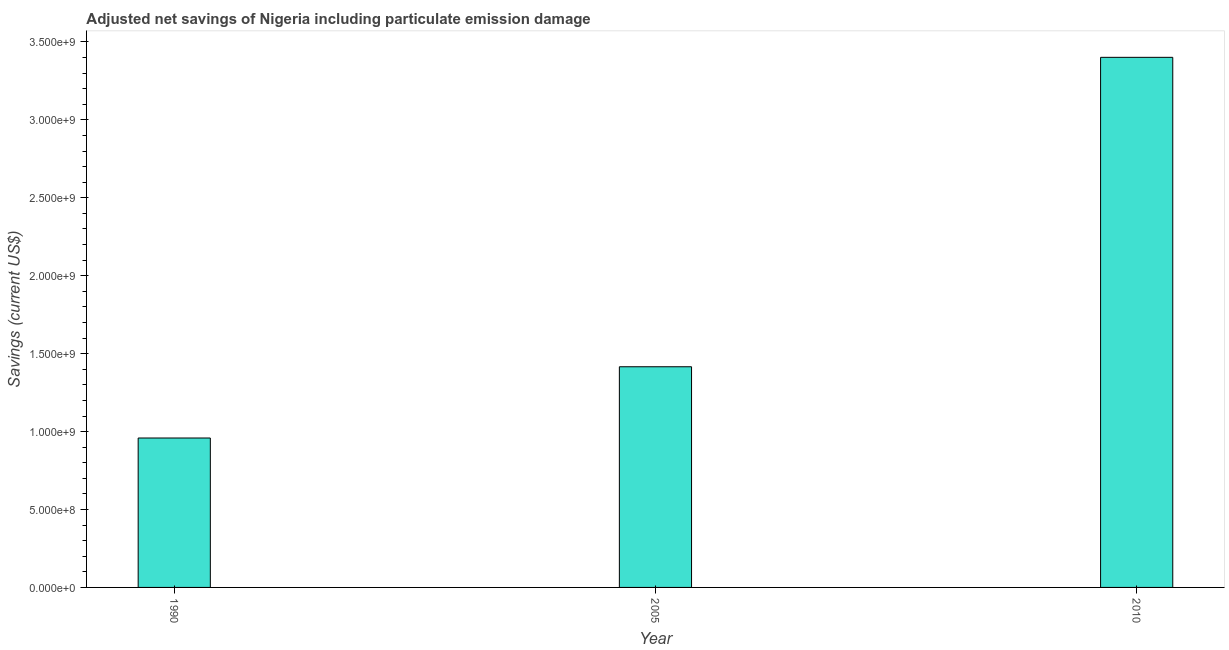Does the graph contain any zero values?
Your response must be concise. No. Does the graph contain grids?
Your answer should be compact. No. What is the title of the graph?
Ensure brevity in your answer.  Adjusted net savings of Nigeria including particulate emission damage. What is the label or title of the Y-axis?
Offer a terse response. Savings (current US$). What is the adjusted net savings in 1990?
Give a very brief answer. 9.59e+08. Across all years, what is the maximum adjusted net savings?
Offer a very short reply. 3.40e+09. Across all years, what is the minimum adjusted net savings?
Give a very brief answer. 9.59e+08. In which year was the adjusted net savings maximum?
Offer a very short reply. 2010. What is the sum of the adjusted net savings?
Your answer should be very brief. 5.78e+09. What is the difference between the adjusted net savings in 1990 and 2010?
Offer a terse response. -2.44e+09. What is the average adjusted net savings per year?
Provide a short and direct response. 1.93e+09. What is the median adjusted net savings?
Offer a very short reply. 1.42e+09. Do a majority of the years between 2010 and 2005 (inclusive) have adjusted net savings greater than 500000000 US$?
Your answer should be compact. No. What is the ratio of the adjusted net savings in 2005 to that in 2010?
Offer a very short reply. 0.42. Is the adjusted net savings in 1990 less than that in 2005?
Provide a short and direct response. Yes. What is the difference between the highest and the second highest adjusted net savings?
Provide a short and direct response. 1.99e+09. What is the difference between the highest and the lowest adjusted net savings?
Make the answer very short. 2.44e+09. In how many years, is the adjusted net savings greater than the average adjusted net savings taken over all years?
Provide a short and direct response. 1. What is the difference between two consecutive major ticks on the Y-axis?
Keep it short and to the point. 5.00e+08. What is the Savings (current US$) of 1990?
Ensure brevity in your answer.  9.59e+08. What is the Savings (current US$) in 2005?
Make the answer very short. 1.42e+09. What is the Savings (current US$) of 2010?
Your answer should be very brief. 3.40e+09. What is the difference between the Savings (current US$) in 1990 and 2005?
Your answer should be very brief. -4.57e+08. What is the difference between the Savings (current US$) in 1990 and 2010?
Offer a terse response. -2.44e+09. What is the difference between the Savings (current US$) in 2005 and 2010?
Your response must be concise. -1.99e+09. What is the ratio of the Savings (current US$) in 1990 to that in 2005?
Provide a short and direct response. 0.68. What is the ratio of the Savings (current US$) in 1990 to that in 2010?
Provide a short and direct response. 0.28. What is the ratio of the Savings (current US$) in 2005 to that in 2010?
Your response must be concise. 0.42. 